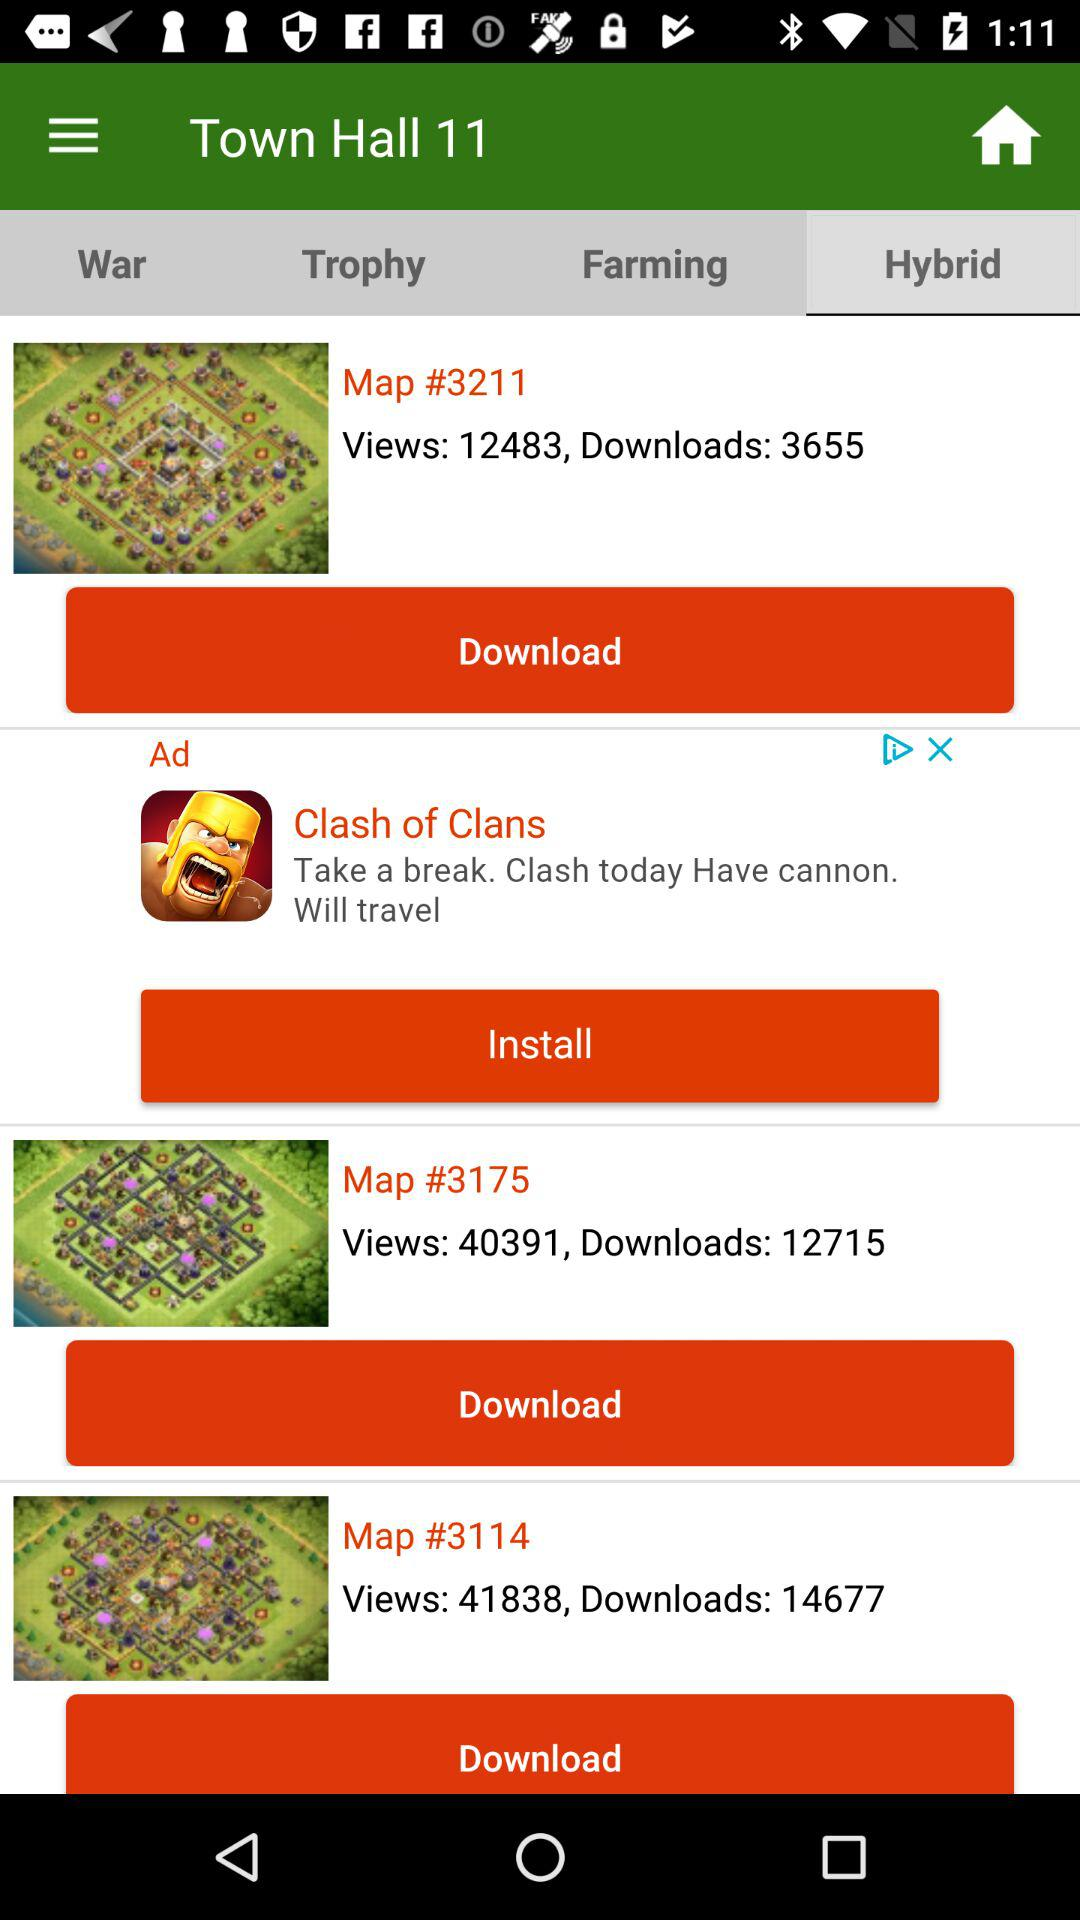How many downloads are there on "Map #3114"? There are 14677 downloads. 